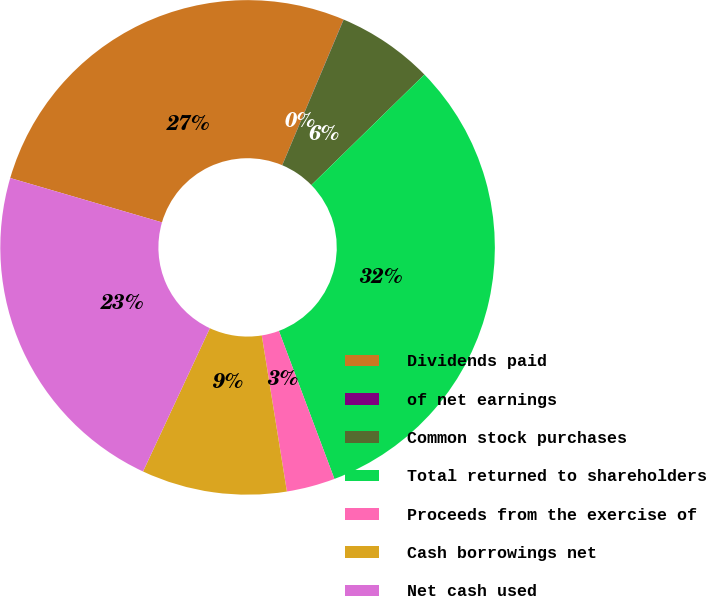Convert chart. <chart><loc_0><loc_0><loc_500><loc_500><pie_chart><fcel>Dividends paid<fcel>of net earnings<fcel>Common stock purchases<fcel>Total returned to shareholders<fcel>Proceeds from the exercise of<fcel>Cash borrowings net<fcel>Net cash used<nl><fcel>26.82%<fcel>0.01%<fcel>6.33%<fcel>31.61%<fcel>3.17%<fcel>9.49%<fcel>22.58%<nl></chart> 